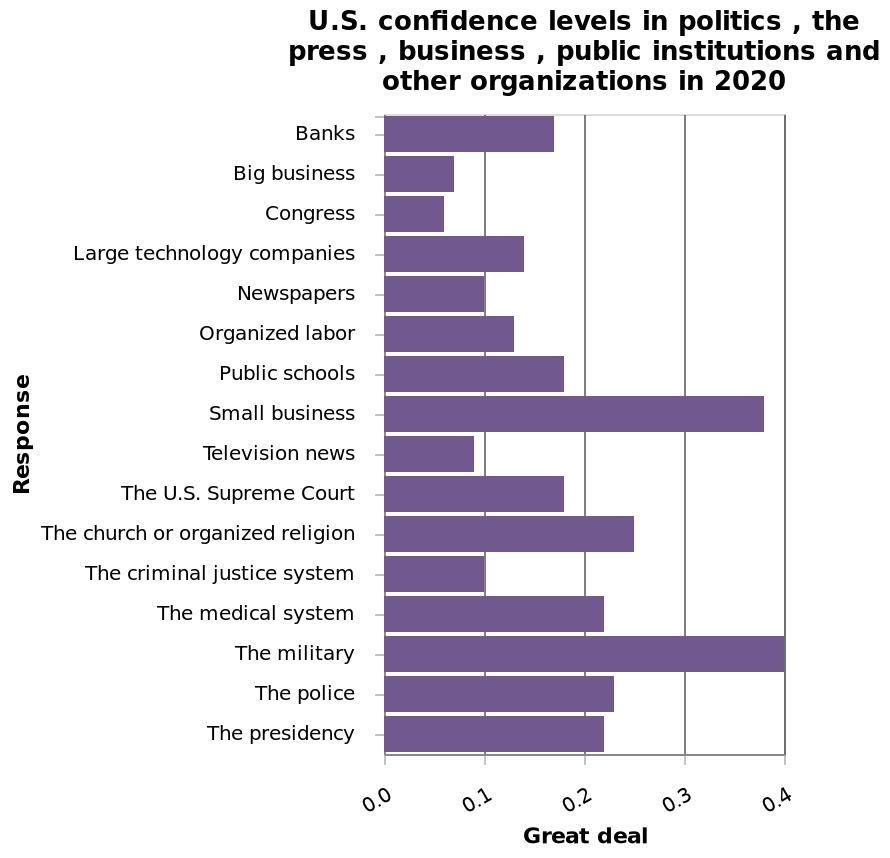<image>
What does the y-axis represent in the bar diagram? The y-axis represents "Response" with a categorical scale starting at Banks and ending at other organizations. What is the title of the bar diagram? The title of the bar diagram is "U.S. confidence levels in politics, the press, business, public institutions, and other organizations in 2020." What is the range of confidence level responses for other areas? The range of confidence level responses for other areas is between 0.1 and 0.25. Which group had the highest confidence levels in politics, the press, business and other public institutions?  Small businesses and the military. 